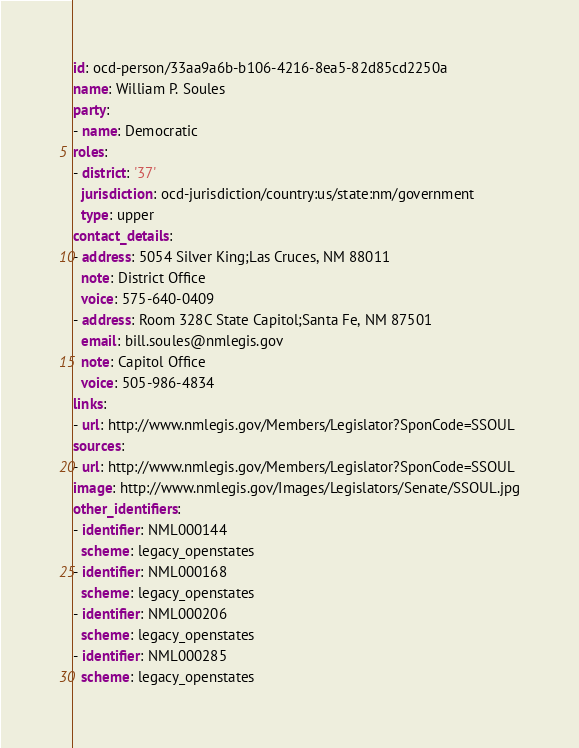<code> <loc_0><loc_0><loc_500><loc_500><_YAML_>id: ocd-person/33aa9a6b-b106-4216-8ea5-82d85cd2250a
name: William P. Soules
party:
- name: Democratic
roles:
- district: '37'
  jurisdiction: ocd-jurisdiction/country:us/state:nm/government
  type: upper
contact_details:
- address: 5054 Silver King;Las Cruces, NM 88011
  note: District Office
  voice: 575-640-0409
- address: Room 328C State Capitol;Santa Fe, NM 87501
  email: bill.soules@nmlegis.gov
  note: Capitol Office
  voice: 505-986-4834
links:
- url: http://www.nmlegis.gov/Members/Legislator?SponCode=SSOUL
sources:
- url: http://www.nmlegis.gov/Members/Legislator?SponCode=SSOUL
image: http://www.nmlegis.gov/Images/Legislators/Senate/SSOUL.jpg
other_identifiers:
- identifier: NML000144
  scheme: legacy_openstates
- identifier: NML000168
  scheme: legacy_openstates
- identifier: NML000206
  scheme: legacy_openstates
- identifier: NML000285
  scheme: legacy_openstates
</code> 